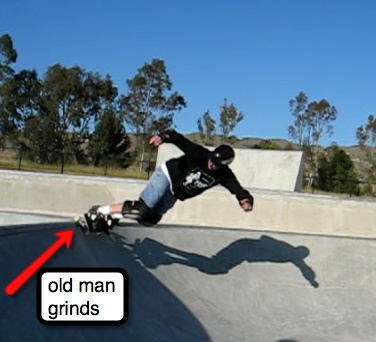Describe the objects in this image and their specific colors. I can see people in gray, black, darkgray, and lightgray tones and skateboard in gray, black, darkgray, and lightgray tones in this image. 